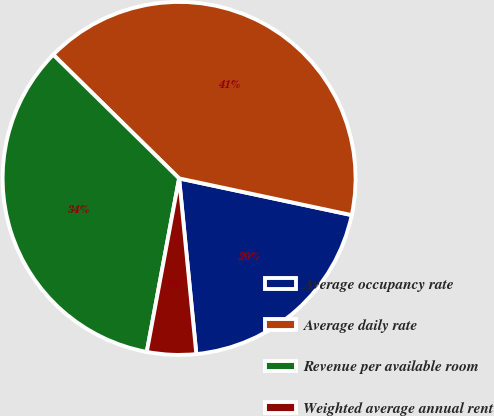Convert chart. <chart><loc_0><loc_0><loc_500><loc_500><pie_chart><fcel>Average occupancy rate<fcel>Average daily rate<fcel>Revenue per available room<fcel>Weighted average annual rent<nl><fcel>20.11%<fcel>40.97%<fcel>34.43%<fcel>4.49%<nl></chart> 